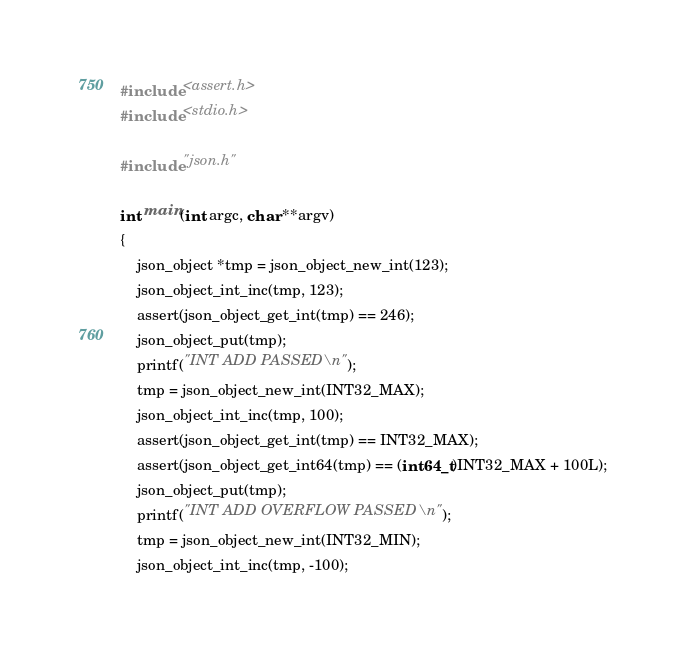Convert code to text. <code><loc_0><loc_0><loc_500><loc_500><_C_>#include <assert.h>
#include <stdio.h>

#include "json.h"

int main(int argc, char **argv)
{
	json_object *tmp = json_object_new_int(123);
	json_object_int_inc(tmp, 123);
	assert(json_object_get_int(tmp) == 246);
	json_object_put(tmp);
	printf("INT ADD PASSED\n");
	tmp = json_object_new_int(INT32_MAX);
	json_object_int_inc(tmp, 100);
	assert(json_object_get_int(tmp) == INT32_MAX);
	assert(json_object_get_int64(tmp) == (int64_t)INT32_MAX + 100L);
	json_object_put(tmp);
	printf("INT ADD OVERFLOW PASSED\n");
	tmp = json_object_new_int(INT32_MIN);
	json_object_int_inc(tmp, -100);</code> 